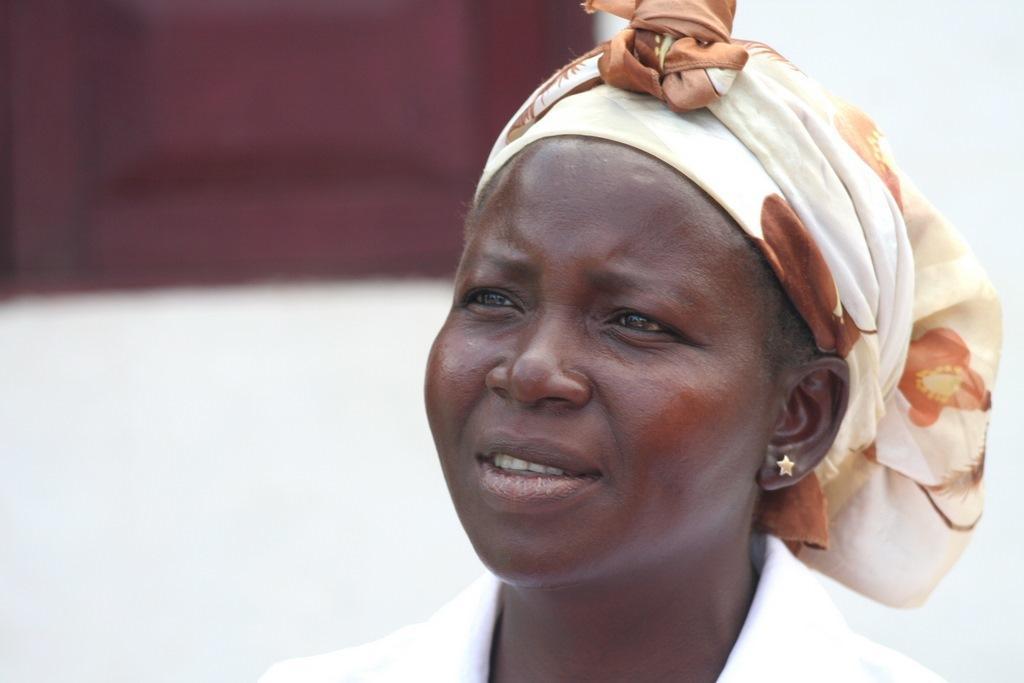Could you give a brief overview of what you see in this image? In this picture I can see a woman and she wore a cloth on her head and looks like a window to the wall on the back. 